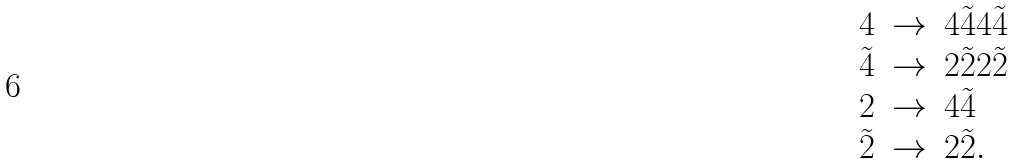<formula> <loc_0><loc_0><loc_500><loc_500>\begin{array} { l c l } 4 & \to & 4 \tilde { 4 } 4 \tilde { 4 } \\ \tilde { 4 } & \to & 2 \tilde { 2 } 2 \tilde { 2 } \\ 2 & \to & 4 \tilde { 4 } \\ \tilde { 2 } & \to & 2 \tilde { 2 } . \end{array}</formula> 